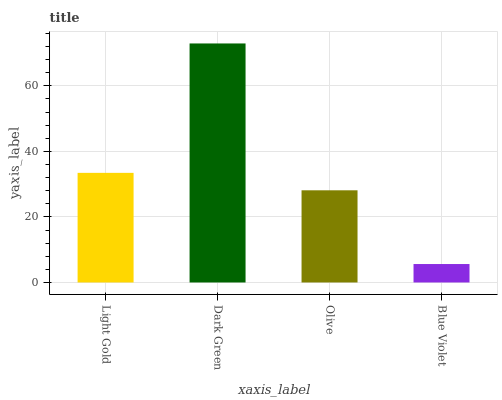Is Olive the minimum?
Answer yes or no. No. Is Olive the maximum?
Answer yes or no. No. Is Dark Green greater than Olive?
Answer yes or no. Yes. Is Olive less than Dark Green?
Answer yes or no. Yes. Is Olive greater than Dark Green?
Answer yes or no. No. Is Dark Green less than Olive?
Answer yes or no. No. Is Light Gold the high median?
Answer yes or no. Yes. Is Olive the low median?
Answer yes or no. Yes. Is Dark Green the high median?
Answer yes or no. No. Is Blue Violet the low median?
Answer yes or no. No. 